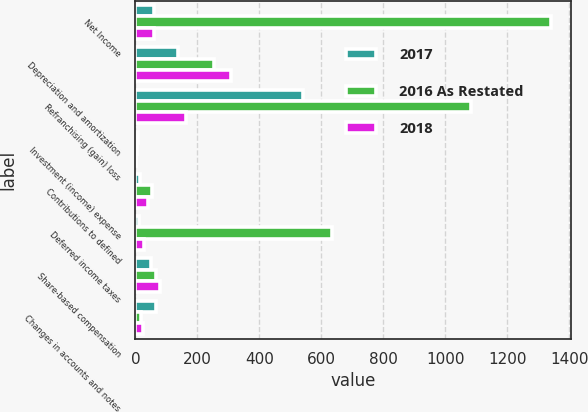<chart> <loc_0><loc_0><loc_500><loc_500><stacked_bar_chart><ecel><fcel>Net Income<fcel>Depreciation and amortization<fcel>Refranchising (gain) loss<fcel>Investment (income) expense<fcel>Contributions to defined<fcel>Deferred income taxes<fcel>Share-based compensation<fcel>Changes in accounts and notes<nl><fcel>2017<fcel>60<fcel>137<fcel>540<fcel>9<fcel>16<fcel>11<fcel>50<fcel>66<nl><fcel>2016 As Restated<fcel>1340<fcel>253<fcel>1083<fcel>5<fcel>55<fcel>634<fcel>65<fcel>19<nl><fcel>2018<fcel>60<fcel>310<fcel>163<fcel>2<fcel>41<fcel>28<fcel>80<fcel>23<nl></chart> 